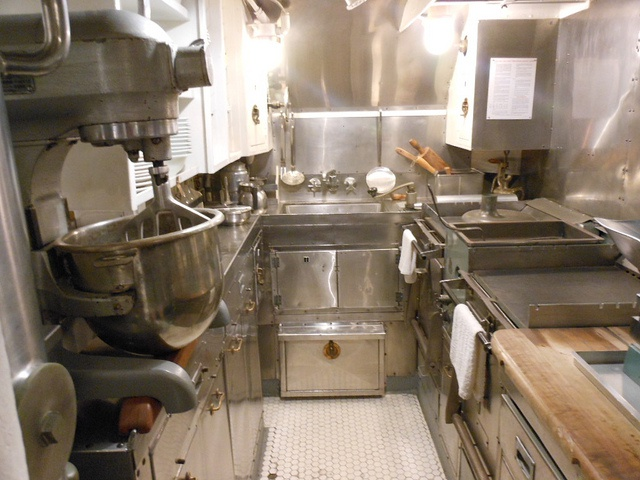Describe the objects in this image and their specific colors. I can see oven in gray and darkgray tones, oven in gray and black tones, sink in gray, darkgray, and lightgray tones, and bowl in gray, darkgray, and lightgray tones in this image. 